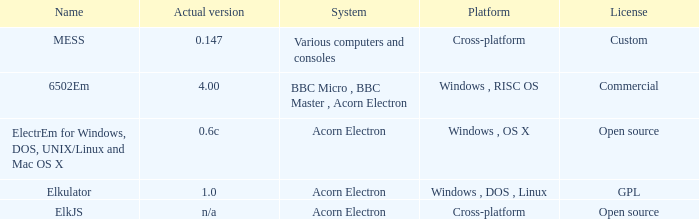What is the name of the system referred to as elkjs? Acorn Electron. 